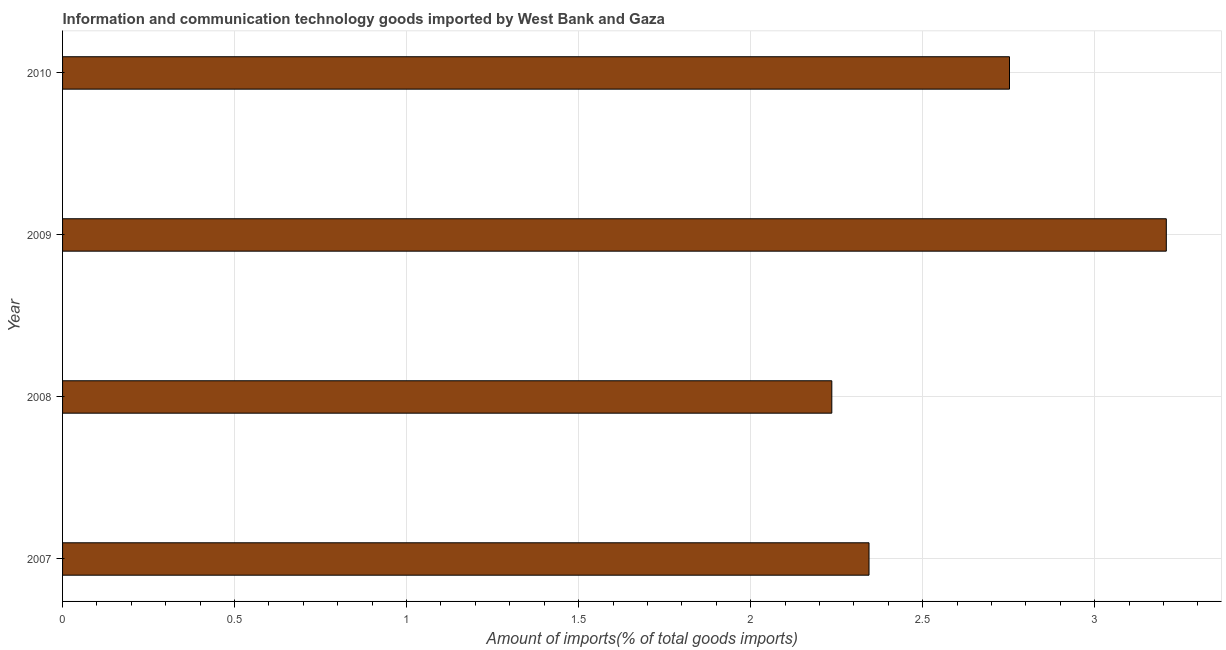Does the graph contain any zero values?
Make the answer very short. No. Does the graph contain grids?
Provide a succinct answer. Yes. What is the title of the graph?
Make the answer very short. Information and communication technology goods imported by West Bank and Gaza. What is the label or title of the X-axis?
Provide a succinct answer. Amount of imports(% of total goods imports). What is the label or title of the Y-axis?
Ensure brevity in your answer.  Year. What is the amount of ict goods imports in 2008?
Make the answer very short. 2.24. Across all years, what is the maximum amount of ict goods imports?
Provide a short and direct response. 3.21. Across all years, what is the minimum amount of ict goods imports?
Make the answer very short. 2.24. In which year was the amount of ict goods imports minimum?
Your response must be concise. 2008. What is the sum of the amount of ict goods imports?
Offer a terse response. 10.54. What is the difference between the amount of ict goods imports in 2008 and 2010?
Offer a very short reply. -0.52. What is the average amount of ict goods imports per year?
Ensure brevity in your answer.  2.63. What is the median amount of ict goods imports?
Your answer should be compact. 2.55. In how many years, is the amount of ict goods imports greater than 3.1 %?
Make the answer very short. 1. What is the ratio of the amount of ict goods imports in 2007 to that in 2009?
Your answer should be compact. 0.73. Is the amount of ict goods imports in 2009 less than that in 2010?
Give a very brief answer. No. What is the difference between the highest and the second highest amount of ict goods imports?
Ensure brevity in your answer.  0.46. Is the sum of the amount of ict goods imports in 2007 and 2010 greater than the maximum amount of ict goods imports across all years?
Give a very brief answer. Yes. How many bars are there?
Give a very brief answer. 4. How many years are there in the graph?
Provide a succinct answer. 4. Are the values on the major ticks of X-axis written in scientific E-notation?
Offer a very short reply. No. What is the Amount of imports(% of total goods imports) of 2007?
Offer a terse response. 2.34. What is the Amount of imports(% of total goods imports) of 2008?
Ensure brevity in your answer.  2.24. What is the Amount of imports(% of total goods imports) in 2009?
Your answer should be compact. 3.21. What is the Amount of imports(% of total goods imports) in 2010?
Your response must be concise. 2.75. What is the difference between the Amount of imports(% of total goods imports) in 2007 and 2008?
Provide a short and direct response. 0.11. What is the difference between the Amount of imports(% of total goods imports) in 2007 and 2009?
Give a very brief answer. -0.86. What is the difference between the Amount of imports(% of total goods imports) in 2007 and 2010?
Your response must be concise. -0.41. What is the difference between the Amount of imports(% of total goods imports) in 2008 and 2009?
Your response must be concise. -0.97. What is the difference between the Amount of imports(% of total goods imports) in 2008 and 2010?
Ensure brevity in your answer.  -0.52. What is the difference between the Amount of imports(% of total goods imports) in 2009 and 2010?
Your answer should be compact. 0.46. What is the ratio of the Amount of imports(% of total goods imports) in 2007 to that in 2008?
Ensure brevity in your answer.  1.05. What is the ratio of the Amount of imports(% of total goods imports) in 2007 to that in 2009?
Your response must be concise. 0.73. What is the ratio of the Amount of imports(% of total goods imports) in 2007 to that in 2010?
Give a very brief answer. 0.85. What is the ratio of the Amount of imports(% of total goods imports) in 2008 to that in 2009?
Give a very brief answer. 0.7. What is the ratio of the Amount of imports(% of total goods imports) in 2008 to that in 2010?
Provide a succinct answer. 0.81. What is the ratio of the Amount of imports(% of total goods imports) in 2009 to that in 2010?
Ensure brevity in your answer.  1.17. 